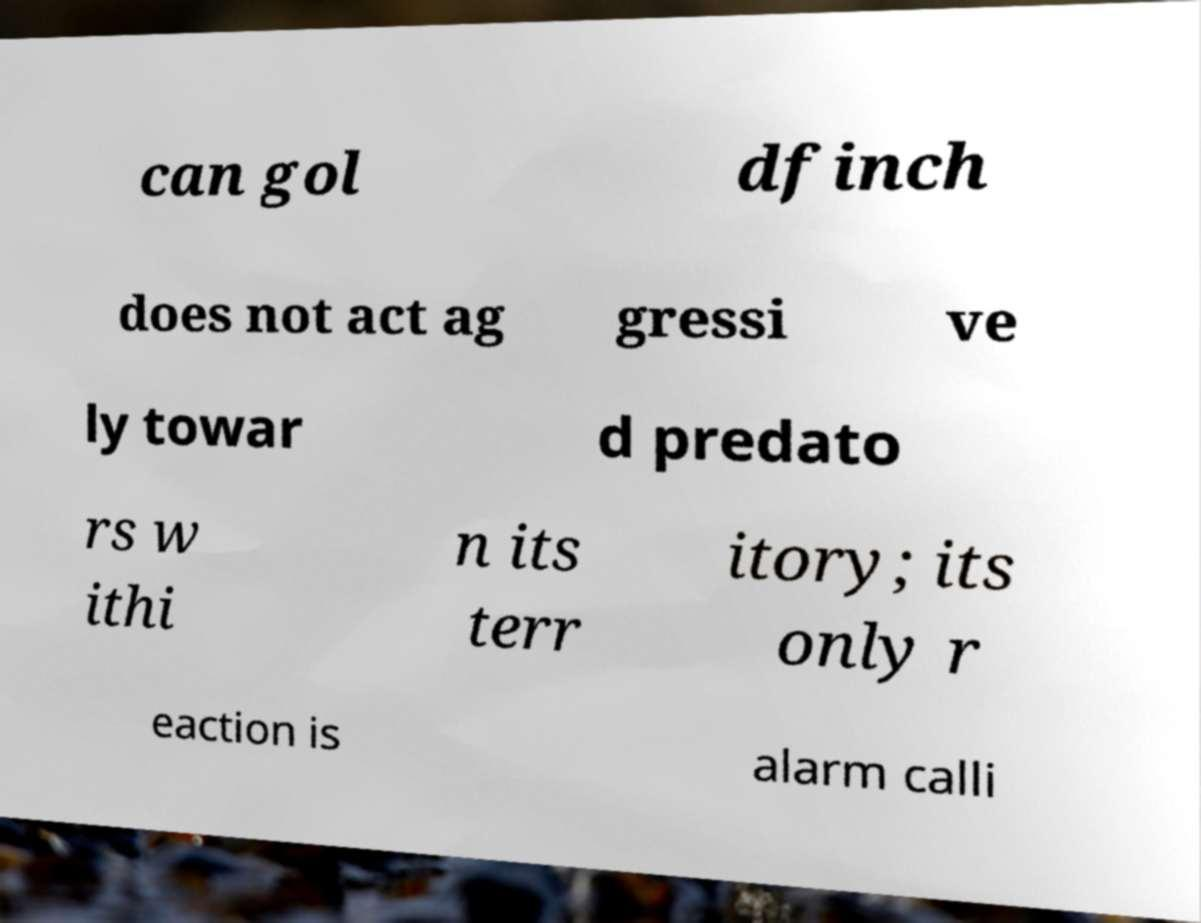Could you extract and type out the text from this image? can gol dfinch does not act ag gressi ve ly towar d predato rs w ithi n its terr itory; its only r eaction is alarm calli 